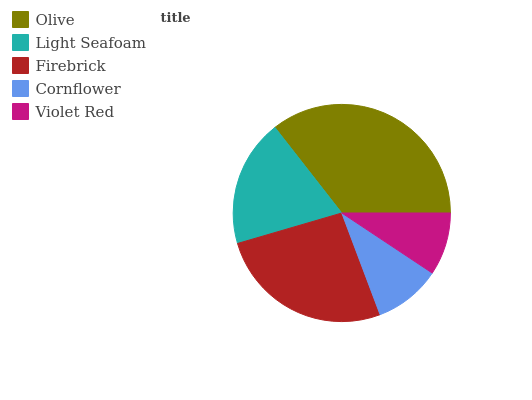Is Violet Red the minimum?
Answer yes or no. Yes. Is Olive the maximum?
Answer yes or no. Yes. Is Light Seafoam the minimum?
Answer yes or no. No. Is Light Seafoam the maximum?
Answer yes or no. No. Is Olive greater than Light Seafoam?
Answer yes or no. Yes. Is Light Seafoam less than Olive?
Answer yes or no. Yes. Is Light Seafoam greater than Olive?
Answer yes or no. No. Is Olive less than Light Seafoam?
Answer yes or no. No. Is Light Seafoam the high median?
Answer yes or no. Yes. Is Light Seafoam the low median?
Answer yes or no. Yes. Is Cornflower the high median?
Answer yes or no. No. Is Cornflower the low median?
Answer yes or no. No. 